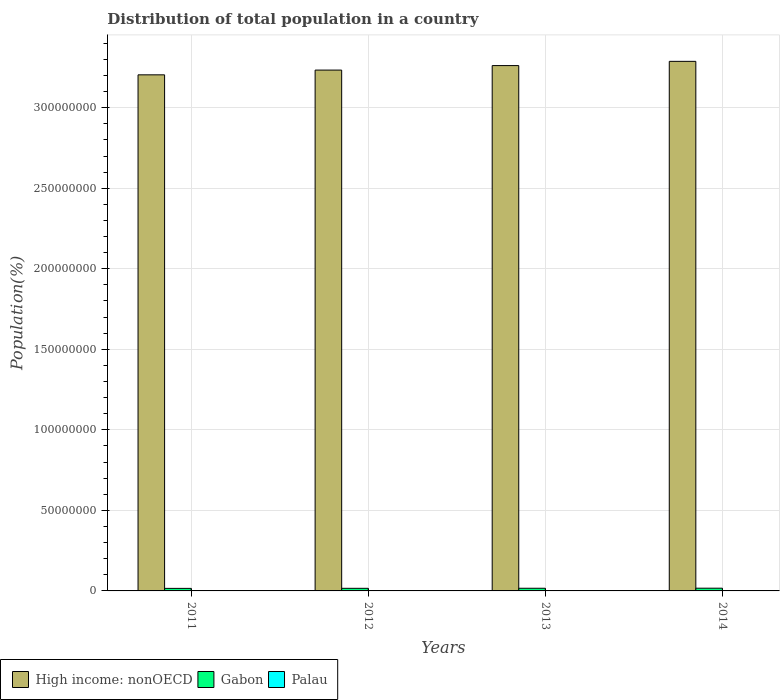How many groups of bars are there?
Provide a short and direct response. 4. Are the number of bars on each tick of the X-axis equal?
Your answer should be compact. Yes. How many bars are there on the 4th tick from the left?
Ensure brevity in your answer.  3. What is the label of the 1st group of bars from the left?
Keep it short and to the point. 2011. What is the population of in Gabon in 2011?
Provide a short and direct response. 1.58e+06. Across all years, what is the maximum population of in High income: nonOECD?
Offer a terse response. 3.29e+08. Across all years, what is the minimum population of in High income: nonOECD?
Ensure brevity in your answer.  3.20e+08. In which year was the population of in Gabon maximum?
Make the answer very short. 2014. What is the total population of in Palau in the graph?
Your answer should be compact. 8.34e+04. What is the difference between the population of in Palau in 2012 and that in 2014?
Offer a very short reply. -341. What is the difference between the population of in Palau in 2012 and the population of in Gabon in 2013?
Make the answer very short. -1.63e+06. What is the average population of in Gabon per year?
Your answer should be very brief. 1.63e+06. In the year 2014, what is the difference between the population of in Palau and population of in Gabon?
Provide a succinct answer. -1.67e+06. In how many years, is the population of in Gabon greater than 190000000 %?
Offer a very short reply. 0. What is the ratio of the population of in High income: nonOECD in 2011 to that in 2012?
Ensure brevity in your answer.  0.99. Is the difference between the population of in Palau in 2013 and 2014 greater than the difference between the population of in Gabon in 2013 and 2014?
Your answer should be compact. Yes. What is the difference between the highest and the second highest population of in Gabon?
Keep it short and to the point. 3.73e+04. What is the difference between the highest and the lowest population of in Gabon?
Your answer should be very brief. 1.10e+05. Is the sum of the population of in Gabon in 2012 and 2013 greater than the maximum population of in Palau across all years?
Make the answer very short. Yes. What does the 2nd bar from the left in 2012 represents?
Make the answer very short. Gabon. What does the 2nd bar from the right in 2014 represents?
Your answer should be very brief. Gabon. Are all the bars in the graph horizontal?
Your answer should be compact. No. What is the difference between two consecutive major ticks on the Y-axis?
Offer a terse response. 5.00e+07. Does the graph contain any zero values?
Your answer should be very brief. No. Where does the legend appear in the graph?
Your answer should be compact. Bottom left. How many legend labels are there?
Provide a short and direct response. 3. How are the legend labels stacked?
Give a very brief answer. Horizontal. What is the title of the graph?
Your answer should be very brief. Distribution of total population in a country. What is the label or title of the X-axis?
Provide a short and direct response. Years. What is the label or title of the Y-axis?
Offer a terse response. Population(%). What is the Population(%) in High income: nonOECD in 2011?
Provide a succinct answer. 3.20e+08. What is the Population(%) in Gabon in 2011?
Your answer should be very brief. 1.58e+06. What is the Population(%) in Palau in 2011?
Provide a short and direct response. 2.06e+04. What is the Population(%) of High income: nonOECD in 2012?
Provide a succinct answer. 3.23e+08. What is the Population(%) in Gabon in 2012?
Your answer should be very brief. 1.61e+06. What is the Population(%) in Palau in 2012?
Your answer should be compact. 2.08e+04. What is the Population(%) of High income: nonOECD in 2013?
Ensure brevity in your answer.  3.26e+08. What is the Population(%) of Gabon in 2013?
Give a very brief answer. 1.65e+06. What is the Population(%) of Palau in 2013?
Your response must be concise. 2.09e+04. What is the Population(%) of High income: nonOECD in 2014?
Provide a short and direct response. 3.29e+08. What is the Population(%) of Gabon in 2014?
Your response must be concise. 1.69e+06. What is the Population(%) in Palau in 2014?
Provide a succinct answer. 2.11e+04. Across all years, what is the maximum Population(%) in High income: nonOECD?
Provide a short and direct response. 3.29e+08. Across all years, what is the maximum Population(%) in Gabon?
Ensure brevity in your answer.  1.69e+06. Across all years, what is the maximum Population(%) of Palau?
Keep it short and to the point. 2.11e+04. Across all years, what is the minimum Population(%) of High income: nonOECD?
Provide a short and direct response. 3.20e+08. Across all years, what is the minimum Population(%) of Gabon?
Your answer should be very brief. 1.58e+06. Across all years, what is the minimum Population(%) in Palau?
Your answer should be very brief. 2.06e+04. What is the total Population(%) of High income: nonOECD in the graph?
Ensure brevity in your answer.  1.30e+09. What is the total Population(%) of Gabon in the graph?
Your answer should be compact. 6.53e+06. What is the total Population(%) of Palau in the graph?
Ensure brevity in your answer.  8.34e+04. What is the difference between the Population(%) in High income: nonOECD in 2011 and that in 2012?
Provide a short and direct response. -2.95e+06. What is the difference between the Population(%) in Gabon in 2011 and that in 2012?
Ensure brevity in your answer.  -3.62e+04. What is the difference between the Population(%) in Palau in 2011 and that in 2012?
Offer a very short reply. -150. What is the difference between the Population(%) in High income: nonOECD in 2011 and that in 2013?
Provide a short and direct response. -5.74e+06. What is the difference between the Population(%) in Gabon in 2011 and that in 2013?
Give a very brief answer. -7.31e+04. What is the difference between the Population(%) in Palau in 2011 and that in 2013?
Keep it short and to the point. -313. What is the difference between the Population(%) in High income: nonOECD in 2011 and that in 2014?
Provide a short and direct response. -8.37e+06. What is the difference between the Population(%) of Gabon in 2011 and that in 2014?
Your answer should be very brief. -1.10e+05. What is the difference between the Population(%) of Palau in 2011 and that in 2014?
Make the answer very short. -491. What is the difference between the Population(%) in High income: nonOECD in 2012 and that in 2013?
Your answer should be compact. -2.79e+06. What is the difference between the Population(%) of Gabon in 2012 and that in 2013?
Your answer should be compact. -3.69e+04. What is the difference between the Population(%) of Palau in 2012 and that in 2013?
Make the answer very short. -163. What is the difference between the Population(%) of High income: nonOECD in 2012 and that in 2014?
Give a very brief answer. -5.42e+06. What is the difference between the Population(%) of Gabon in 2012 and that in 2014?
Your response must be concise. -7.42e+04. What is the difference between the Population(%) in Palau in 2012 and that in 2014?
Ensure brevity in your answer.  -341. What is the difference between the Population(%) in High income: nonOECD in 2013 and that in 2014?
Give a very brief answer. -2.63e+06. What is the difference between the Population(%) of Gabon in 2013 and that in 2014?
Give a very brief answer. -3.73e+04. What is the difference between the Population(%) of Palau in 2013 and that in 2014?
Your answer should be very brief. -178. What is the difference between the Population(%) of High income: nonOECD in 2011 and the Population(%) of Gabon in 2012?
Give a very brief answer. 3.19e+08. What is the difference between the Population(%) of High income: nonOECD in 2011 and the Population(%) of Palau in 2012?
Your answer should be compact. 3.20e+08. What is the difference between the Population(%) in Gabon in 2011 and the Population(%) in Palau in 2012?
Provide a short and direct response. 1.56e+06. What is the difference between the Population(%) of High income: nonOECD in 2011 and the Population(%) of Gabon in 2013?
Your answer should be compact. 3.19e+08. What is the difference between the Population(%) of High income: nonOECD in 2011 and the Population(%) of Palau in 2013?
Ensure brevity in your answer.  3.20e+08. What is the difference between the Population(%) in Gabon in 2011 and the Population(%) in Palau in 2013?
Provide a short and direct response. 1.56e+06. What is the difference between the Population(%) in High income: nonOECD in 2011 and the Population(%) in Gabon in 2014?
Ensure brevity in your answer.  3.19e+08. What is the difference between the Population(%) of High income: nonOECD in 2011 and the Population(%) of Palau in 2014?
Keep it short and to the point. 3.20e+08. What is the difference between the Population(%) in Gabon in 2011 and the Population(%) in Palau in 2014?
Provide a short and direct response. 1.56e+06. What is the difference between the Population(%) in High income: nonOECD in 2012 and the Population(%) in Gabon in 2013?
Provide a succinct answer. 3.22e+08. What is the difference between the Population(%) of High income: nonOECD in 2012 and the Population(%) of Palau in 2013?
Make the answer very short. 3.23e+08. What is the difference between the Population(%) in Gabon in 2012 and the Population(%) in Palau in 2013?
Your answer should be very brief. 1.59e+06. What is the difference between the Population(%) of High income: nonOECD in 2012 and the Population(%) of Gabon in 2014?
Your answer should be compact. 3.22e+08. What is the difference between the Population(%) in High income: nonOECD in 2012 and the Population(%) in Palau in 2014?
Give a very brief answer. 3.23e+08. What is the difference between the Population(%) in Gabon in 2012 and the Population(%) in Palau in 2014?
Keep it short and to the point. 1.59e+06. What is the difference between the Population(%) in High income: nonOECD in 2013 and the Population(%) in Gabon in 2014?
Make the answer very short. 3.24e+08. What is the difference between the Population(%) in High income: nonOECD in 2013 and the Population(%) in Palau in 2014?
Give a very brief answer. 3.26e+08. What is the difference between the Population(%) in Gabon in 2013 and the Population(%) in Palau in 2014?
Give a very brief answer. 1.63e+06. What is the average Population(%) in High income: nonOECD per year?
Give a very brief answer. 3.25e+08. What is the average Population(%) of Gabon per year?
Provide a succinct answer. 1.63e+06. What is the average Population(%) of Palau per year?
Keep it short and to the point. 2.08e+04. In the year 2011, what is the difference between the Population(%) in High income: nonOECD and Population(%) in Gabon?
Keep it short and to the point. 3.19e+08. In the year 2011, what is the difference between the Population(%) of High income: nonOECD and Population(%) of Palau?
Offer a very short reply. 3.20e+08. In the year 2011, what is the difference between the Population(%) in Gabon and Population(%) in Palau?
Provide a short and direct response. 1.56e+06. In the year 2012, what is the difference between the Population(%) in High income: nonOECD and Population(%) in Gabon?
Your answer should be very brief. 3.22e+08. In the year 2012, what is the difference between the Population(%) of High income: nonOECD and Population(%) of Palau?
Make the answer very short. 3.23e+08. In the year 2012, what is the difference between the Population(%) of Gabon and Population(%) of Palau?
Ensure brevity in your answer.  1.59e+06. In the year 2013, what is the difference between the Population(%) in High income: nonOECD and Population(%) in Gabon?
Give a very brief answer. 3.24e+08. In the year 2013, what is the difference between the Population(%) of High income: nonOECD and Population(%) of Palau?
Your answer should be very brief. 3.26e+08. In the year 2013, what is the difference between the Population(%) of Gabon and Population(%) of Palau?
Give a very brief answer. 1.63e+06. In the year 2014, what is the difference between the Population(%) of High income: nonOECD and Population(%) of Gabon?
Offer a terse response. 3.27e+08. In the year 2014, what is the difference between the Population(%) in High income: nonOECD and Population(%) in Palau?
Your answer should be very brief. 3.29e+08. In the year 2014, what is the difference between the Population(%) in Gabon and Population(%) in Palau?
Keep it short and to the point. 1.67e+06. What is the ratio of the Population(%) of High income: nonOECD in 2011 to that in 2012?
Offer a terse response. 0.99. What is the ratio of the Population(%) in Gabon in 2011 to that in 2012?
Offer a terse response. 0.98. What is the ratio of the Population(%) in High income: nonOECD in 2011 to that in 2013?
Your answer should be compact. 0.98. What is the ratio of the Population(%) in Gabon in 2011 to that in 2013?
Make the answer very short. 0.96. What is the ratio of the Population(%) of High income: nonOECD in 2011 to that in 2014?
Keep it short and to the point. 0.97. What is the ratio of the Population(%) in Gabon in 2011 to that in 2014?
Your answer should be compact. 0.93. What is the ratio of the Population(%) in Palau in 2011 to that in 2014?
Give a very brief answer. 0.98. What is the ratio of the Population(%) in High income: nonOECD in 2012 to that in 2013?
Make the answer very short. 0.99. What is the ratio of the Population(%) in Gabon in 2012 to that in 2013?
Keep it short and to the point. 0.98. What is the ratio of the Population(%) of High income: nonOECD in 2012 to that in 2014?
Provide a short and direct response. 0.98. What is the ratio of the Population(%) of Gabon in 2012 to that in 2014?
Provide a succinct answer. 0.96. What is the ratio of the Population(%) in Palau in 2012 to that in 2014?
Give a very brief answer. 0.98. What is the ratio of the Population(%) in High income: nonOECD in 2013 to that in 2014?
Make the answer very short. 0.99. What is the ratio of the Population(%) of Gabon in 2013 to that in 2014?
Provide a succinct answer. 0.98. What is the ratio of the Population(%) of Palau in 2013 to that in 2014?
Make the answer very short. 0.99. What is the difference between the highest and the second highest Population(%) in High income: nonOECD?
Provide a succinct answer. 2.63e+06. What is the difference between the highest and the second highest Population(%) in Gabon?
Your answer should be very brief. 3.73e+04. What is the difference between the highest and the second highest Population(%) of Palau?
Offer a very short reply. 178. What is the difference between the highest and the lowest Population(%) in High income: nonOECD?
Give a very brief answer. 8.37e+06. What is the difference between the highest and the lowest Population(%) of Gabon?
Ensure brevity in your answer.  1.10e+05. What is the difference between the highest and the lowest Population(%) in Palau?
Your answer should be compact. 491. 